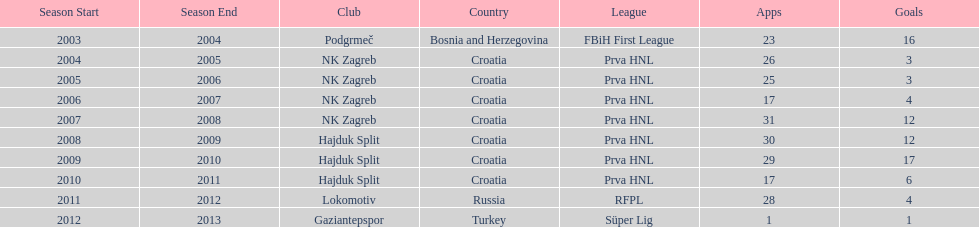At most 26 apps, how many goals were scored in 2004-2005 3. Could you parse the entire table as a dict? {'header': ['Season Start', 'Season End', 'Club', 'Country', 'League', 'Apps', 'Goals'], 'rows': [['2003', '2004', 'Podgrmeč', 'Bosnia and Herzegovina', 'FBiH First League', '23', '16'], ['2004', '2005', 'NK Zagreb', 'Croatia', 'Prva HNL', '26', '3'], ['2005', '2006', 'NK Zagreb', 'Croatia', 'Prva HNL', '25', '3'], ['2006', '2007', 'NK Zagreb', 'Croatia', 'Prva HNL', '17', '4'], ['2007', '2008', 'NK Zagreb', 'Croatia', 'Prva HNL', '31', '12'], ['2008', '2009', 'Hajduk Split', 'Croatia', 'Prva HNL', '30', '12'], ['2009', '2010', 'Hajduk Split', 'Croatia', 'Prva HNL', '29', '17'], ['2010', '2011', 'Hajduk Split', 'Croatia', 'Prva HNL', '17', '6'], ['2011', '2012', 'Lokomotiv', 'Russia', 'RFPL', '28', '4'], ['2012', '2013', 'Gaziantepspor', 'Turkey', 'Süper Lig', '1', '1']]} 